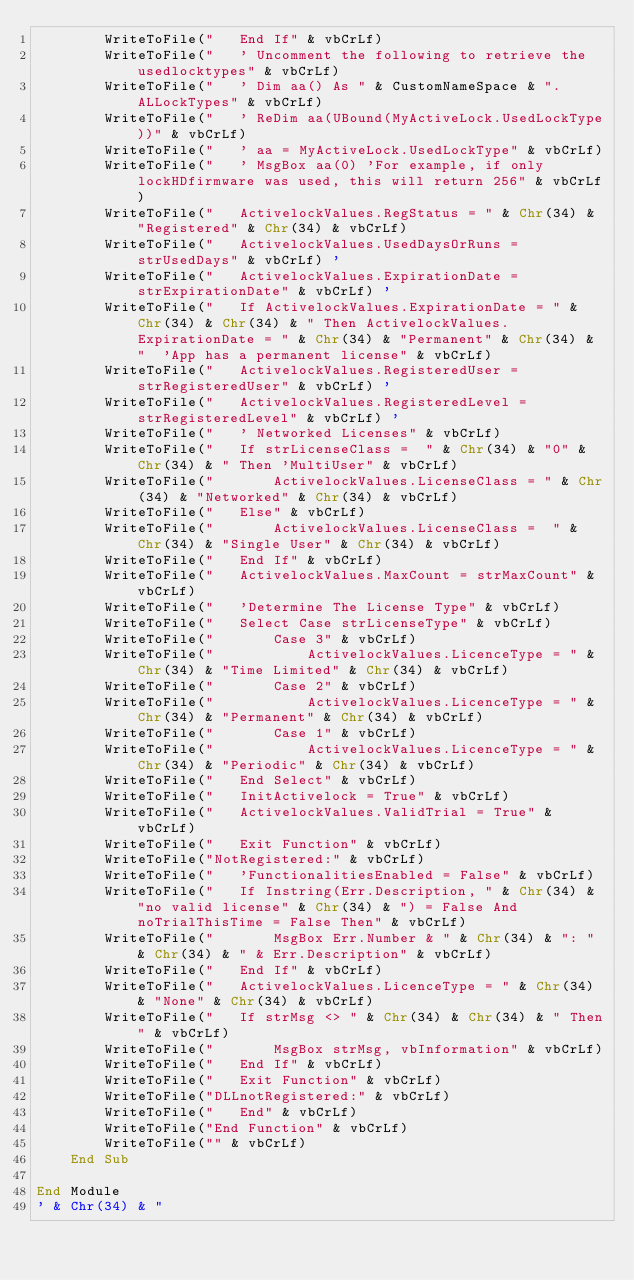Convert code to text. <code><loc_0><loc_0><loc_500><loc_500><_VisualBasic_>        WriteToFile("   End If" & vbCrLf)
        WriteToFile("   ' Uncomment the following to retrieve the usedlocktypes" & vbCrLf)
        WriteToFile("   ' Dim aa() As " & CustomNameSpace & ".ALLockTypes" & vbCrLf)
        WriteToFile("   ' ReDim aa(UBound(MyActiveLock.UsedLockType))" & vbCrLf)
        WriteToFile("   ' aa = MyActiveLock.UsedLockType" & vbCrLf)
        WriteToFile("   ' MsgBox aa(0) 'For example, if only lockHDfirmware was used, this will return 256" & vbCrLf)
        WriteToFile("   ActivelockValues.RegStatus = " & Chr(34) & "Registered" & Chr(34) & vbCrLf)
        WriteToFile("   ActivelockValues.UsedDaysOrRuns = strUsedDays" & vbCrLf) '
        WriteToFile("   ActivelockValues.ExpirationDate = strExpirationDate" & vbCrLf) '
        WriteToFile("   If ActivelockValues.ExpirationDate = " & Chr(34) & Chr(34) & " Then ActivelockValues.ExpirationDate = " & Chr(34) & "Permanent" & Chr(34) & "  'App has a permanent license" & vbCrLf)
        WriteToFile("   ActivelockValues.RegisteredUser = strRegisteredUser" & vbCrLf) '
        WriteToFile("   ActivelockValues.RegisteredLevel = strRegisteredLevel" & vbCrLf) '
        WriteToFile("   ' Networked Licenses" & vbCrLf)
        WriteToFile("   If strLicenseClass =  " & Chr(34) & "0" & Chr(34) & " Then 'MultiUser" & vbCrLf)
        WriteToFile("       ActivelockValues.LicenseClass = " & Chr(34) & "Networked" & Chr(34) & vbCrLf)
        WriteToFile("   Else" & vbCrLf)
        WriteToFile("       ActivelockValues.LicenseClass =  " & Chr(34) & "Single User" & Chr(34) & vbCrLf)
        WriteToFile("   End If" & vbCrLf)
        WriteToFile("   ActivelockValues.MaxCount = strMaxCount" & vbCrLf)
        WriteToFile("   'Determine The License Type" & vbCrLf)
        WriteToFile("   Select Case strLicenseType" & vbCrLf)
        WriteToFile("       Case 3" & vbCrLf)
        WriteToFile("           ActivelockValues.LicenceType = " & Chr(34) & "Time Limited" & Chr(34) & vbCrLf)
        WriteToFile("       Case 2" & vbCrLf)
        WriteToFile("           ActivelockValues.LicenceType = " & Chr(34) & "Permanent" & Chr(34) & vbCrLf)
        WriteToFile("       Case 1" & vbCrLf)
        WriteToFile("           ActivelockValues.LicenceType = " & Chr(34) & "Periodic" & Chr(34) & vbCrLf)
        WriteToFile("   End Select" & vbCrLf)
        WriteToFile("   InitActivelock = True" & vbCrLf)
        WriteToFile("   ActivelockValues.ValidTrial = True" & vbCrLf)
        WriteToFile("   Exit Function" & vbCrLf)
        WriteToFile("NotRegistered:" & vbCrLf)
        WriteToFile("   'FunctionalitiesEnabled = False" & vbCrLf)
        WriteToFile("   If Instring(Err.Description, " & Chr(34) & "no valid license" & Chr(34) & ") = False And noTrialThisTime = False Then" & vbCrLf)
        WriteToFile("       MsgBox Err.Number & " & Chr(34) & ": " & Chr(34) & " & Err.Description" & vbCrLf)
        WriteToFile("   End If" & vbCrLf)
        WriteToFile("   ActivelockValues.LicenceType = " & Chr(34) & "None" & Chr(34) & vbCrLf)
        WriteToFile("   If strMsg <> " & Chr(34) & Chr(34) & " Then" & vbCrLf)
        WriteToFile("       MsgBox strMsg, vbInformation" & vbCrLf)
        WriteToFile("   End If" & vbCrLf)
        WriteToFile("   Exit Function" & vbCrLf)
        WriteToFile("DLLnotRegistered:" & vbCrLf)
        WriteToFile("   End" & vbCrLf)
        WriteToFile("End Function" & vbCrLf)
        WriteToFile("" & vbCrLf)
    End Sub

End Module
' & Chr(34) & "</code> 